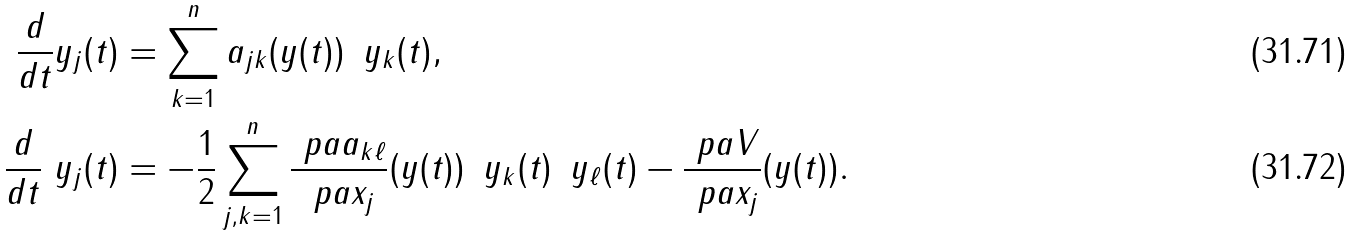<formula> <loc_0><loc_0><loc_500><loc_500>\frac { d } { d t } y _ { j } ( t ) & = \sum _ { k = 1 } ^ { n } a _ { j k } ( y ( t ) ) \, \ y _ { k } ( t ) , \\ \frac { d } { d t } \ y _ { j } ( t ) & = - \frac { 1 } { 2 } \sum _ { j , k = 1 } ^ { n } \frac { \ p a a _ { k \ell } } { \ p a x _ { j } } ( y ( t ) ) \, \ y _ { k } ( t ) \, \ y _ { \ell } ( t ) - \frac { \ p a V } { \ p a x _ { j } } ( y ( t ) ) .</formula> 